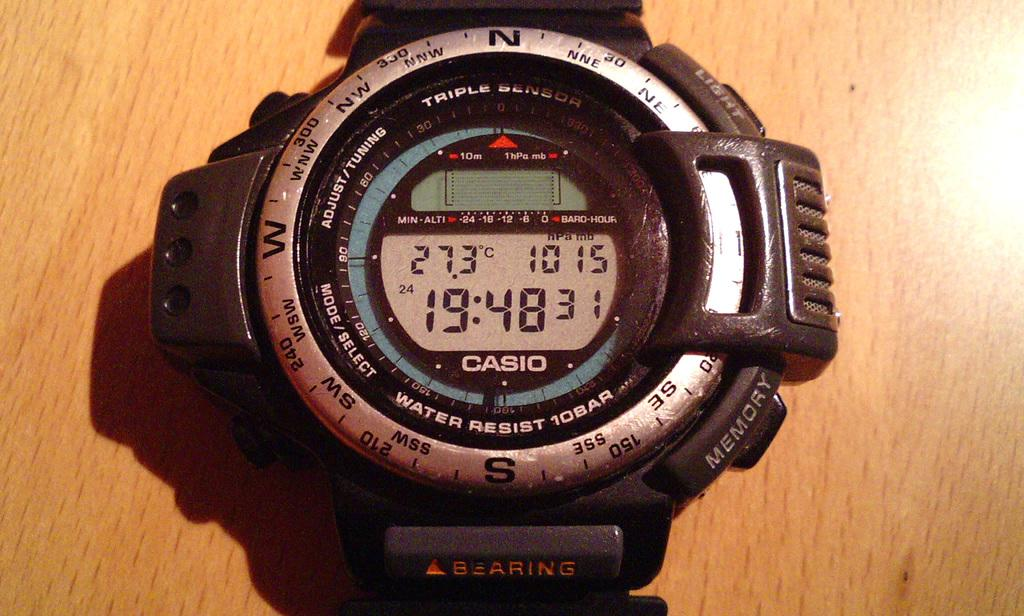Provide a one-sentence caption for the provided image. White and silver wristwatch which says CASIO on it. 